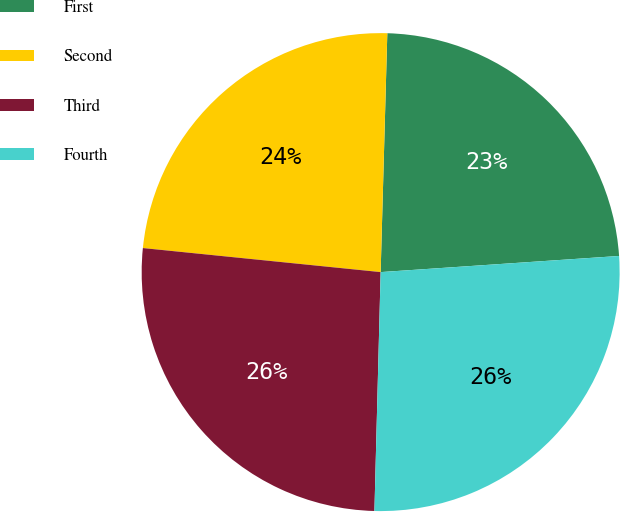Convert chart. <chart><loc_0><loc_0><loc_500><loc_500><pie_chart><fcel>First<fcel>Second<fcel>Third<fcel>Fourth<nl><fcel>23.48%<fcel>23.84%<fcel>26.19%<fcel>26.49%<nl></chart> 